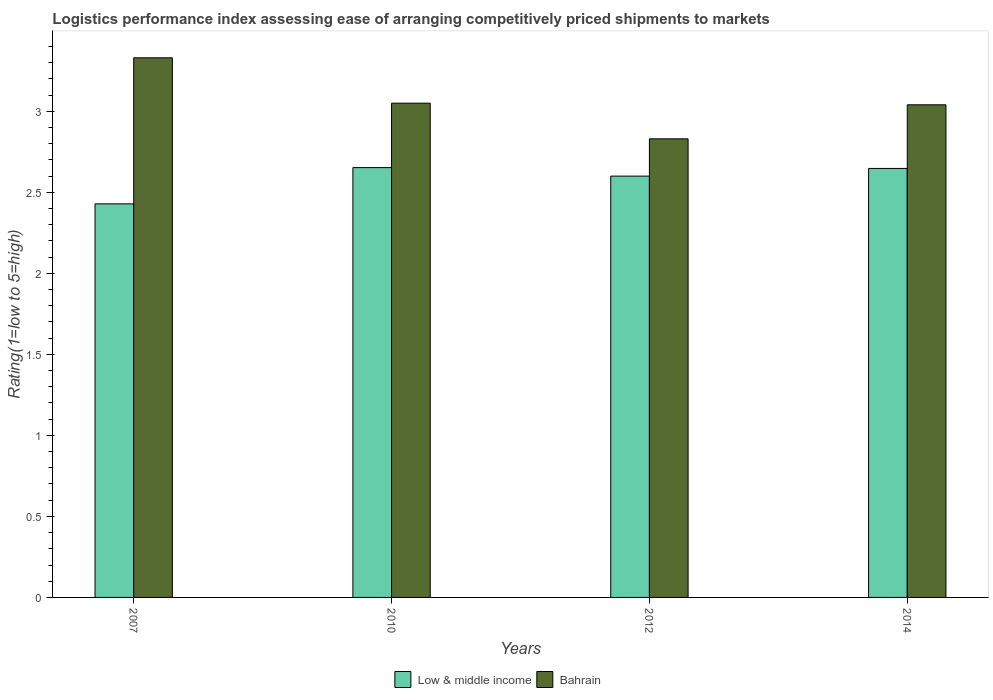How many different coloured bars are there?
Your response must be concise. 2. Are the number of bars per tick equal to the number of legend labels?
Offer a terse response. Yes. How many bars are there on the 1st tick from the left?
Your answer should be compact. 2. How many bars are there on the 1st tick from the right?
Your answer should be very brief. 2. What is the label of the 4th group of bars from the left?
Your answer should be very brief. 2014. In how many cases, is the number of bars for a given year not equal to the number of legend labels?
Give a very brief answer. 0. What is the Logistic performance index in Low & middle income in 2012?
Your answer should be very brief. 2.6. Across all years, what is the maximum Logistic performance index in Low & middle income?
Offer a terse response. 2.65. Across all years, what is the minimum Logistic performance index in Low & middle income?
Make the answer very short. 2.43. In which year was the Logistic performance index in Low & middle income maximum?
Your answer should be very brief. 2010. In which year was the Logistic performance index in Low & middle income minimum?
Your response must be concise. 2007. What is the total Logistic performance index in Bahrain in the graph?
Offer a terse response. 12.25. What is the difference between the Logistic performance index in Bahrain in 2010 and that in 2014?
Your answer should be compact. 0.01. What is the difference between the Logistic performance index in Bahrain in 2007 and the Logistic performance index in Low & middle income in 2014?
Provide a succinct answer. 0.68. What is the average Logistic performance index in Low & middle income per year?
Provide a short and direct response. 2.58. In the year 2012, what is the difference between the Logistic performance index in Bahrain and Logistic performance index in Low & middle income?
Ensure brevity in your answer.  0.23. In how many years, is the Logistic performance index in Bahrain greater than 2.9?
Offer a very short reply. 3. What is the ratio of the Logistic performance index in Bahrain in 2012 to that in 2014?
Provide a short and direct response. 0.93. What is the difference between the highest and the second highest Logistic performance index in Low & middle income?
Your answer should be very brief. 0.01. What is the difference between the highest and the lowest Logistic performance index in Bahrain?
Your response must be concise. 0.5. In how many years, is the Logistic performance index in Low & middle income greater than the average Logistic performance index in Low & middle income taken over all years?
Offer a very short reply. 3. How many bars are there?
Your response must be concise. 8. What is the difference between two consecutive major ticks on the Y-axis?
Ensure brevity in your answer.  0.5. Are the values on the major ticks of Y-axis written in scientific E-notation?
Ensure brevity in your answer.  No. Where does the legend appear in the graph?
Your response must be concise. Bottom center. How are the legend labels stacked?
Provide a short and direct response. Horizontal. What is the title of the graph?
Ensure brevity in your answer.  Logistics performance index assessing ease of arranging competitively priced shipments to markets. Does "American Samoa" appear as one of the legend labels in the graph?
Give a very brief answer. No. What is the label or title of the X-axis?
Keep it short and to the point. Years. What is the label or title of the Y-axis?
Your answer should be very brief. Rating(1=low to 5=high). What is the Rating(1=low to 5=high) of Low & middle income in 2007?
Your response must be concise. 2.43. What is the Rating(1=low to 5=high) in Bahrain in 2007?
Provide a succinct answer. 3.33. What is the Rating(1=low to 5=high) in Low & middle income in 2010?
Ensure brevity in your answer.  2.65. What is the Rating(1=low to 5=high) of Bahrain in 2010?
Provide a short and direct response. 3.05. What is the Rating(1=low to 5=high) in Low & middle income in 2012?
Your answer should be compact. 2.6. What is the Rating(1=low to 5=high) in Bahrain in 2012?
Your response must be concise. 2.83. What is the Rating(1=low to 5=high) of Low & middle income in 2014?
Offer a terse response. 2.65. What is the Rating(1=low to 5=high) in Bahrain in 2014?
Your answer should be very brief. 3.04. Across all years, what is the maximum Rating(1=low to 5=high) of Low & middle income?
Offer a terse response. 2.65. Across all years, what is the maximum Rating(1=low to 5=high) of Bahrain?
Your response must be concise. 3.33. Across all years, what is the minimum Rating(1=low to 5=high) in Low & middle income?
Provide a succinct answer. 2.43. Across all years, what is the minimum Rating(1=low to 5=high) of Bahrain?
Provide a short and direct response. 2.83. What is the total Rating(1=low to 5=high) of Low & middle income in the graph?
Give a very brief answer. 10.33. What is the total Rating(1=low to 5=high) in Bahrain in the graph?
Make the answer very short. 12.25. What is the difference between the Rating(1=low to 5=high) of Low & middle income in 2007 and that in 2010?
Offer a very short reply. -0.22. What is the difference between the Rating(1=low to 5=high) of Bahrain in 2007 and that in 2010?
Make the answer very short. 0.28. What is the difference between the Rating(1=low to 5=high) in Low & middle income in 2007 and that in 2012?
Offer a very short reply. -0.17. What is the difference between the Rating(1=low to 5=high) of Bahrain in 2007 and that in 2012?
Offer a terse response. 0.5. What is the difference between the Rating(1=low to 5=high) in Low & middle income in 2007 and that in 2014?
Provide a succinct answer. -0.22. What is the difference between the Rating(1=low to 5=high) of Bahrain in 2007 and that in 2014?
Provide a succinct answer. 0.29. What is the difference between the Rating(1=low to 5=high) in Low & middle income in 2010 and that in 2012?
Ensure brevity in your answer.  0.05. What is the difference between the Rating(1=low to 5=high) in Bahrain in 2010 and that in 2012?
Offer a terse response. 0.22. What is the difference between the Rating(1=low to 5=high) in Low & middle income in 2010 and that in 2014?
Give a very brief answer. 0.01. What is the difference between the Rating(1=low to 5=high) of Bahrain in 2010 and that in 2014?
Make the answer very short. 0.01. What is the difference between the Rating(1=low to 5=high) of Low & middle income in 2012 and that in 2014?
Provide a succinct answer. -0.05. What is the difference between the Rating(1=low to 5=high) of Bahrain in 2012 and that in 2014?
Offer a terse response. -0.21. What is the difference between the Rating(1=low to 5=high) of Low & middle income in 2007 and the Rating(1=low to 5=high) of Bahrain in 2010?
Provide a succinct answer. -0.62. What is the difference between the Rating(1=low to 5=high) in Low & middle income in 2007 and the Rating(1=low to 5=high) in Bahrain in 2012?
Ensure brevity in your answer.  -0.4. What is the difference between the Rating(1=low to 5=high) in Low & middle income in 2007 and the Rating(1=low to 5=high) in Bahrain in 2014?
Your answer should be very brief. -0.61. What is the difference between the Rating(1=low to 5=high) of Low & middle income in 2010 and the Rating(1=low to 5=high) of Bahrain in 2012?
Give a very brief answer. -0.18. What is the difference between the Rating(1=low to 5=high) in Low & middle income in 2010 and the Rating(1=low to 5=high) in Bahrain in 2014?
Offer a terse response. -0.39. What is the difference between the Rating(1=low to 5=high) of Low & middle income in 2012 and the Rating(1=low to 5=high) of Bahrain in 2014?
Provide a succinct answer. -0.44. What is the average Rating(1=low to 5=high) in Low & middle income per year?
Your answer should be compact. 2.58. What is the average Rating(1=low to 5=high) of Bahrain per year?
Ensure brevity in your answer.  3.06. In the year 2007, what is the difference between the Rating(1=low to 5=high) in Low & middle income and Rating(1=low to 5=high) in Bahrain?
Give a very brief answer. -0.9. In the year 2010, what is the difference between the Rating(1=low to 5=high) in Low & middle income and Rating(1=low to 5=high) in Bahrain?
Offer a very short reply. -0.4. In the year 2012, what is the difference between the Rating(1=low to 5=high) of Low & middle income and Rating(1=low to 5=high) of Bahrain?
Offer a terse response. -0.23. In the year 2014, what is the difference between the Rating(1=low to 5=high) of Low & middle income and Rating(1=low to 5=high) of Bahrain?
Your response must be concise. -0.39. What is the ratio of the Rating(1=low to 5=high) of Low & middle income in 2007 to that in 2010?
Ensure brevity in your answer.  0.92. What is the ratio of the Rating(1=low to 5=high) of Bahrain in 2007 to that in 2010?
Your answer should be very brief. 1.09. What is the ratio of the Rating(1=low to 5=high) of Low & middle income in 2007 to that in 2012?
Provide a succinct answer. 0.93. What is the ratio of the Rating(1=low to 5=high) in Bahrain in 2007 to that in 2012?
Offer a terse response. 1.18. What is the ratio of the Rating(1=low to 5=high) in Low & middle income in 2007 to that in 2014?
Your response must be concise. 0.92. What is the ratio of the Rating(1=low to 5=high) in Bahrain in 2007 to that in 2014?
Keep it short and to the point. 1.1. What is the ratio of the Rating(1=low to 5=high) of Low & middle income in 2010 to that in 2012?
Provide a short and direct response. 1.02. What is the ratio of the Rating(1=low to 5=high) in Bahrain in 2010 to that in 2012?
Offer a terse response. 1.08. What is the ratio of the Rating(1=low to 5=high) in Low & middle income in 2012 to that in 2014?
Provide a succinct answer. 0.98. What is the ratio of the Rating(1=low to 5=high) of Bahrain in 2012 to that in 2014?
Keep it short and to the point. 0.93. What is the difference between the highest and the second highest Rating(1=low to 5=high) of Low & middle income?
Offer a very short reply. 0.01. What is the difference between the highest and the second highest Rating(1=low to 5=high) in Bahrain?
Your response must be concise. 0.28. What is the difference between the highest and the lowest Rating(1=low to 5=high) of Low & middle income?
Provide a short and direct response. 0.22. 